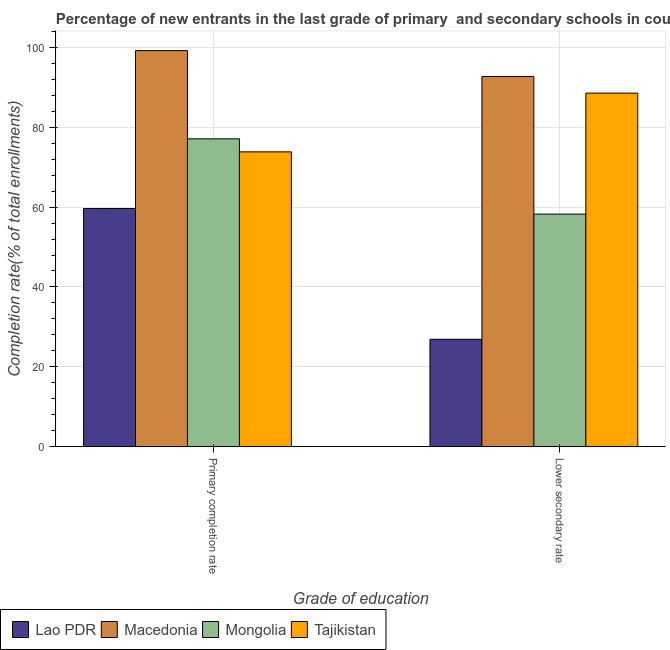Are the number of bars on each tick of the X-axis equal?
Your answer should be very brief. Yes. How many bars are there on the 1st tick from the left?
Make the answer very short. 4. How many bars are there on the 2nd tick from the right?
Offer a very short reply. 4. What is the label of the 2nd group of bars from the left?
Ensure brevity in your answer.  Lower secondary rate. What is the completion rate in secondary schools in Mongolia?
Offer a terse response. 58.24. Across all countries, what is the maximum completion rate in primary schools?
Your answer should be very brief. 99.17. Across all countries, what is the minimum completion rate in primary schools?
Give a very brief answer. 59.65. In which country was the completion rate in secondary schools maximum?
Give a very brief answer. Macedonia. In which country was the completion rate in primary schools minimum?
Make the answer very short. Lao PDR. What is the total completion rate in secondary schools in the graph?
Provide a short and direct response. 266.38. What is the difference between the completion rate in secondary schools in Macedonia and that in Mongolia?
Your response must be concise. 34.47. What is the difference between the completion rate in secondary schools in Mongolia and the completion rate in primary schools in Lao PDR?
Offer a very short reply. -1.41. What is the average completion rate in primary schools per country?
Provide a short and direct response. 77.44. What is the difference between the completion rate in secondary schools and completion rate in primary schools in Mongolia?
Ensure brevity in your answer.  -18.86. What is the ratio of the completion rate in secondary schools in Macedonia to that in Mongolia?
Make the answer very short. 1.59. Is the completion rate in secondary schools in Mongolia less than that in Lao PDR?
Your answer should be very brief. No. What does the 2nd bar from the left in Lower secondary rate represents?
Keep it short and to the point. Macedonia. What does the 2nd bar from the right in Lower secondary rate represents?
Your answer should be compact. Mongolia. How many bars are there?
Your response must be concise. 8. Where does the legend appear in the graph?
Offer a very short reply. Bottom left. How are the legend labels stacked?
Offer a very short reply. Horizontal. What is the title of the graph?
Your response must be concise. Percentage of new entrants in the last grade of primary  and secondary schools in countries. What is the label or title of the X-axis?
Ensure brevity in your answer.  Grade of education. What is the label or title of the Y-axis?
Give a very brief answer. Completion rate(% of total enrollments). What is the Completion rate(% of total enrollments) of Lao PDR in Primary completion rate?
Your answer should be compact. 59.65. What is the Completion rate(% of total enrollments) of Macedonia in Primary completion rate?
Ensure brevity in your answer.  99.17. What is the Completion rate(% of total enrollments) in Mongolia in Primary completion rate?
Provide a short and direct response. 77.09. What is the Completion rate(% of total enrollments) in Tajikistan in Primary completion rate?
Ensure brevity in your answer.  73.83. What is the Completion rate(% of total enrollments) in Lao PDR in Lower secondary rate?
Ensure brevity in your answer.  26.91. What is the Completion rate(% of total enrollments) in Macedonia in Lower secondary rate?
Your response must be concise. 92.7. What is the Completion rate(% of total enrollments) of Mongolia in Lower secondary rate?
Offer a very short reply. 58.24. What is the Completion rate(% of total enrollments) of Tajikistan in Lower secondary rate?
Your answer should be very brief. 88.53. Across all Grade of education, what is the maximum Completion rate(% of total enrollments) of Lao PDR?
Your answer should be very brief. 59.65. Across all Grade of education, what is the maximum Completion rate(% of total enrollments) of Macedonia?
Your answer should be very brief. 99.17. Across all Grade of education, what is the maximum Completion rate(% of total enrollments) in Mongolia?
Give a very brief answer. 77.09. Across all Grade of education, what is the maximum Completion rate(% of total enrollments) in Tajikistan?
Your answer should be compact. 88.53. Across all Grade of education, what is the minimum Completion rate(% of total enrollments) of Lao PDR?
Your answer should be compact. 26.91. Across all Grade of education, what is the minimum Completion rate(% of total enrollments) in Macedonia?
Provide a short and direct response. 92.7. Across all Grade of education, what is the minimum Completion rate(% of total enrollments) in Mongolia?
Provide a succinct answer. 58.24. Across all Grade of education, what is the minimum Completion rate(% of total enrollments) in Tajikistan?
Ensure brevity in your answer.  73.83. What is the total Completion rate(% of total enrollments) of Lao PDR in the graph?
Provide a short and direct response. 86.55. What is the total Completion rate(% of total enrollments) of Macedonia in the graph?
Offer a terse response. 191.88. What is the total Completion rate(% of total enrollments) in Mongolia in the graph?
Provide a short and direct response. 135.33. What is the total Completion rate(% of total enrollments) of Tajikistan in the graph?
Ensure brevity in your answer.  162.36. What is the difference between the Completion rate(% of total enrollments) of Lao PDR in Primary completion rate and that in Lower secondary rate?
Your answer should be compact. 32.74. What is the difference between the Completion rate(% of total enrollments) of Macedonia in Primary completion rate and that in Lower secondary rate?
Make the answer very short. 6.47. What is the difference between the Completion rate(% of total enrollments) in Mongolia in Primary completion rate and that in Lower secondary rate?
Provide a short and direct response. 18.86. What is the difference between the Completion rate(% of total enrollments) of Tajikistan in Primary completion rate and that in Lower secondary rate?
Your response must be concise. -14.7. What is the difference between the Completion rate(% of total enrollments) in Lao PDR in Primary completion rate and the Completion rate(% of total enrollments) in Macedonia in Lower secondary rate?
Your response must be concise. -33.06. What is the difference between the Completion rate(% of total enrollments) of Lao PDR in Primary completion rate and the Completion rate(% of total enrollments) of Mongolia in Lower secondary rate?
Provide a succinct answer. 1.41. What is the difference between the Completion rate(% of total enrollments) of Lao PDR in Primary completion rate and the Completion rate(% of total enrollments) of Tajikistan in Lower secondary rate?
Provide a short and direct response. -28.89. What is the difference between the Completion rate(% of total enrollments) in Macedonia in Primary completion rate and the Completion rate(% of total enrollments) in Mongolia in Lower secondary rate?
Provide a succinct answer. 40.94. What is the difference between the Completion rate(% of total enrollments) of Macedonia in Primary completion rate and the Completion rate(% of total enrollments) of Tajikistan in Lower secondary rate?
Offer a terse response. 10.64. What is the difference between the Completion rate(% of total enrollments) in Mongolia in Primary completion rate and the Completion rate(% of total enrollments) in Tajikistan in Lower secondary rate?
Your answer should be compact. -11.44. What is the average Completion rate(% of total enrollments) of Lao PDR per Grade of education?
Give a very brief answer. 43.28. What is the average Completion rate(% of total enrollments) in Macedonia per Grade of education?
Make the answer very short. 95.94. What is the average Completion rate(% of total enrollments) in Mongolia per Grade of education?
Ensure brevity in your answer.  67.66. What is the average Completion rate(% of total enrollments) in Tajikistan per Grade of education?
Your answer should be very brief. 81.18. What is the difference between the Completion rate(% of total enrollments) in Lao PDR and Completion rate(% of total enrollments) in Macedonia in Primary completion rate?
Make the answer very short. -39.52. What is the difference between the Completion rate(% of total enrollments) of Lao PDR and Completion rate(% of total enrollments) of Mongolia in Primary completion rate?
Provide a short and direct response. -17.45. What is the difference between the Completion rate(% of total enrollments) in Lao PDR and Completion rate(% of total enrollments) in Tajikistan in Primary completion rate?
Your answer should be compact. -14.18. What is the difference between the Completion rate(% of total enrollments) in Macedonia and Completion rate(% of total enrollments) in Mongolia in Primary completion rate?
Offer a very short reply. 22.08. What is the difference between the Completion rate(% of total enrollments) of Macedonia and Completion rate(% of total enrollments) of Tajikistan in Primary completion rate?
Ensure brevity in your answer.  25.34. What is the difference between the Completion rate(% of total enrollments) of Mongolia and Completion rate(% of total enrollments) of Tajikistan in Primary completion rate?
Offer a terse response. 3.26. What is the difference between the Completion rate(% of total enrollments) of Lao PDR and Completion rate(% of total enrollments) of Macedonia in Lower secondary rate?
Provide a succinct answer. -65.8. What is the difference between the Completion rate(% of total enrollments) in Lao PDR and Completion rate(% of total enrollments) in Mongolia in Lower secondary rate?
Ensure brevity in your answer.  -31.33. What is the difference between the Completion rate(% of total enrollments) of Lao PDR and Completion rate(% of total enrollments) of Tajikistan in Lower secondary rate?
Give a very brief answer. -61.63. What is the difference between the Completion rate(% of total enrollments) in Macedonia and Completion rate(% of total enrollments) in Mongolia in Lower secondary rate?
Provide a succinct answer. 34.47. What is the difference between the Completion rate(% of total enrollments) in Macedonia and Completion rate(% of total enrollments) in Tajikistan in Lower secondary rate?
Offer a very short reply. 4.17. What is the difference between the Completion rate(% of total enrollments) of Mongolia and Completion rate(% of total enrollments) of Tajikistan in Lower secondary rate?
Your answer should be very brief. -30.3. What is the ratio of the Completion rate(% of total enrollments) of Lao PDR in Primary completion rate to that in Lower secondary rate?
Offer a very short reply. 2.22. What is the ratio of the Completion rate(% of total enrollments) in Macedonia in Primary completion rate to that in Lower secondary rate?
Provide a succinct answer. 1.07. What is the ratio of the Completion rate(% of total enrollments) of Mongolia in Primary completion rate to that in Lower secondary rate?
Give a very brief answer. 1.32. What is the ratio of the Completion rate(% of total enrollments) of Tajikistan in Primary completion rate to that in Lower secondary rate?
Offer a very short reply. 0.83. What is the difference between the highest and the second highest Completion rate(% of total enrollments) of Lao PDR?
Keep it short and to the point. 32.74. What is the difference between the highest and the second highest Completion rate(% of total enrollments) in Macedonia?
Make the answer very short. 6.47. What is the difference between the highest and the second highest Completion rate(% of total enrollments) in Mongolia?
Offer a terse response. 18.86. What is the difference between the highest and the second highest Completion rate(% of total enrollments) in Tajikistan?
Your answer should be compact. 14.7. What is the difference between the highest and the lowest Completion rate(% of total enrollments) of Lao PDR?
Provide a short and direct response. 32.74. What is the difference between the highest and the lowest Completion rate(% of total enrollments) of Macedonia?
Ensure brevity in your answer.  6.47. What is the difference between the highest and the lowest Completion rate(% of total enrollments) in Mongolia?
Your response must be concise. 18.86. What is the difference between the highest and the lowest Completion rate(% of total enrollments) of Tajikistan?
Your response must be concise. 14.7. 